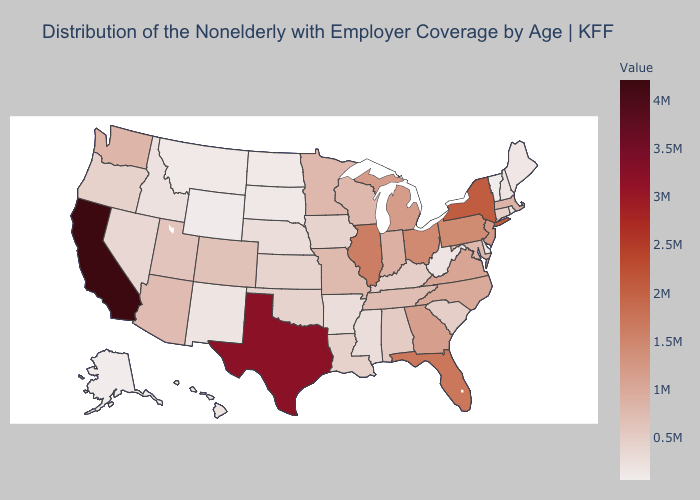Which states have the lowest value in the Northeast?
Answer briefly. Vermont. Among the states that border Florida , which have the lowest value?
Short answer required. Alabama. Among the states that border Connecticut , does Rhode Island have the highest value?
Short answer required. No. Which states have the lowest value in the USA?
Give a very brief answer. Vermont. Among the states that border Utah , which have the highest value?
Write a very short answer. Arizona. 